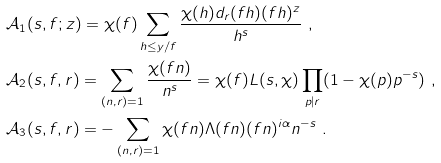<formula> <loc_0><loc_0><loc_500><loc_500>& \mathcal { A } _ { 1 } ( s , f ; z ) = \chi ( f ) \sum _ { h \leq y / f } \frac { \chi ( h ) d _ { r } ( f h ) ( f h ) ^ { z } } { h ^ { s } } \ , \\ & \mathcal { A } _ { 2 } ( s , f , r ) = \sum _ { ( n , r ) = 1 } \frac { \chi ( f n ) } { n ^ { s } } = \chi ( f ) L ( s , \chi ) \prod _ { p | r } ( 1 - \chi ( p ) p ^ { - s } ) \ , \\ & \mathcal { A } _ { 3 } ( s , f , r ) = - \sum _ { ( n , r ) = 1 } \chi ( f n ) \Lambda ( f n ) ( f n ) ^ { i \alpha } n ^ { - s } \ .</formula> 